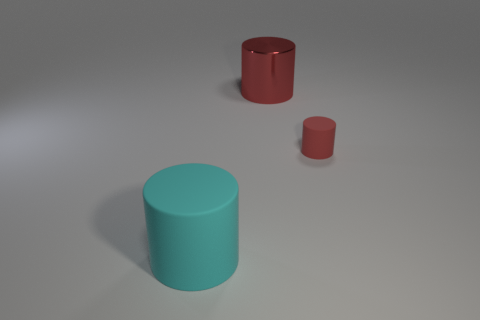Are there any other things that are the same size as the red rubber cylinder?
Give a very brief answer. No. What is the color of the other small object that is the same shape as the cyan thing?
Offer a terse response. Red. Is there any other thing that is made of the same material as the large red object?
Provide a succinct answer. No. There is a red matte object that is the same shape as the big cyan matte thing; what size is it?
Give a very brief answer. Small. There is a thing that is in front of the shiny object and on the right side of the cyan rubber cylinder; what is its material?
Offer a terse response. Rubber. There is a tiny rubber cylinder in front of the big metallic object; is its color the same as the shiny object?
Make the answer very short. Yes. Is the color of the tiny cylinder the same as the big object behind the large cyan cylinder?
Your response must be concise. Yes. There is a big red object; are there any tiny cylinders behind it?
Keep it short and to the point. No. Are the big cyan cylinder and the large red object made of the same material?
Offer a terse response. No. What material is the other thing that is the same size as the cyan object?
Provide a succinct answer. Metal. 